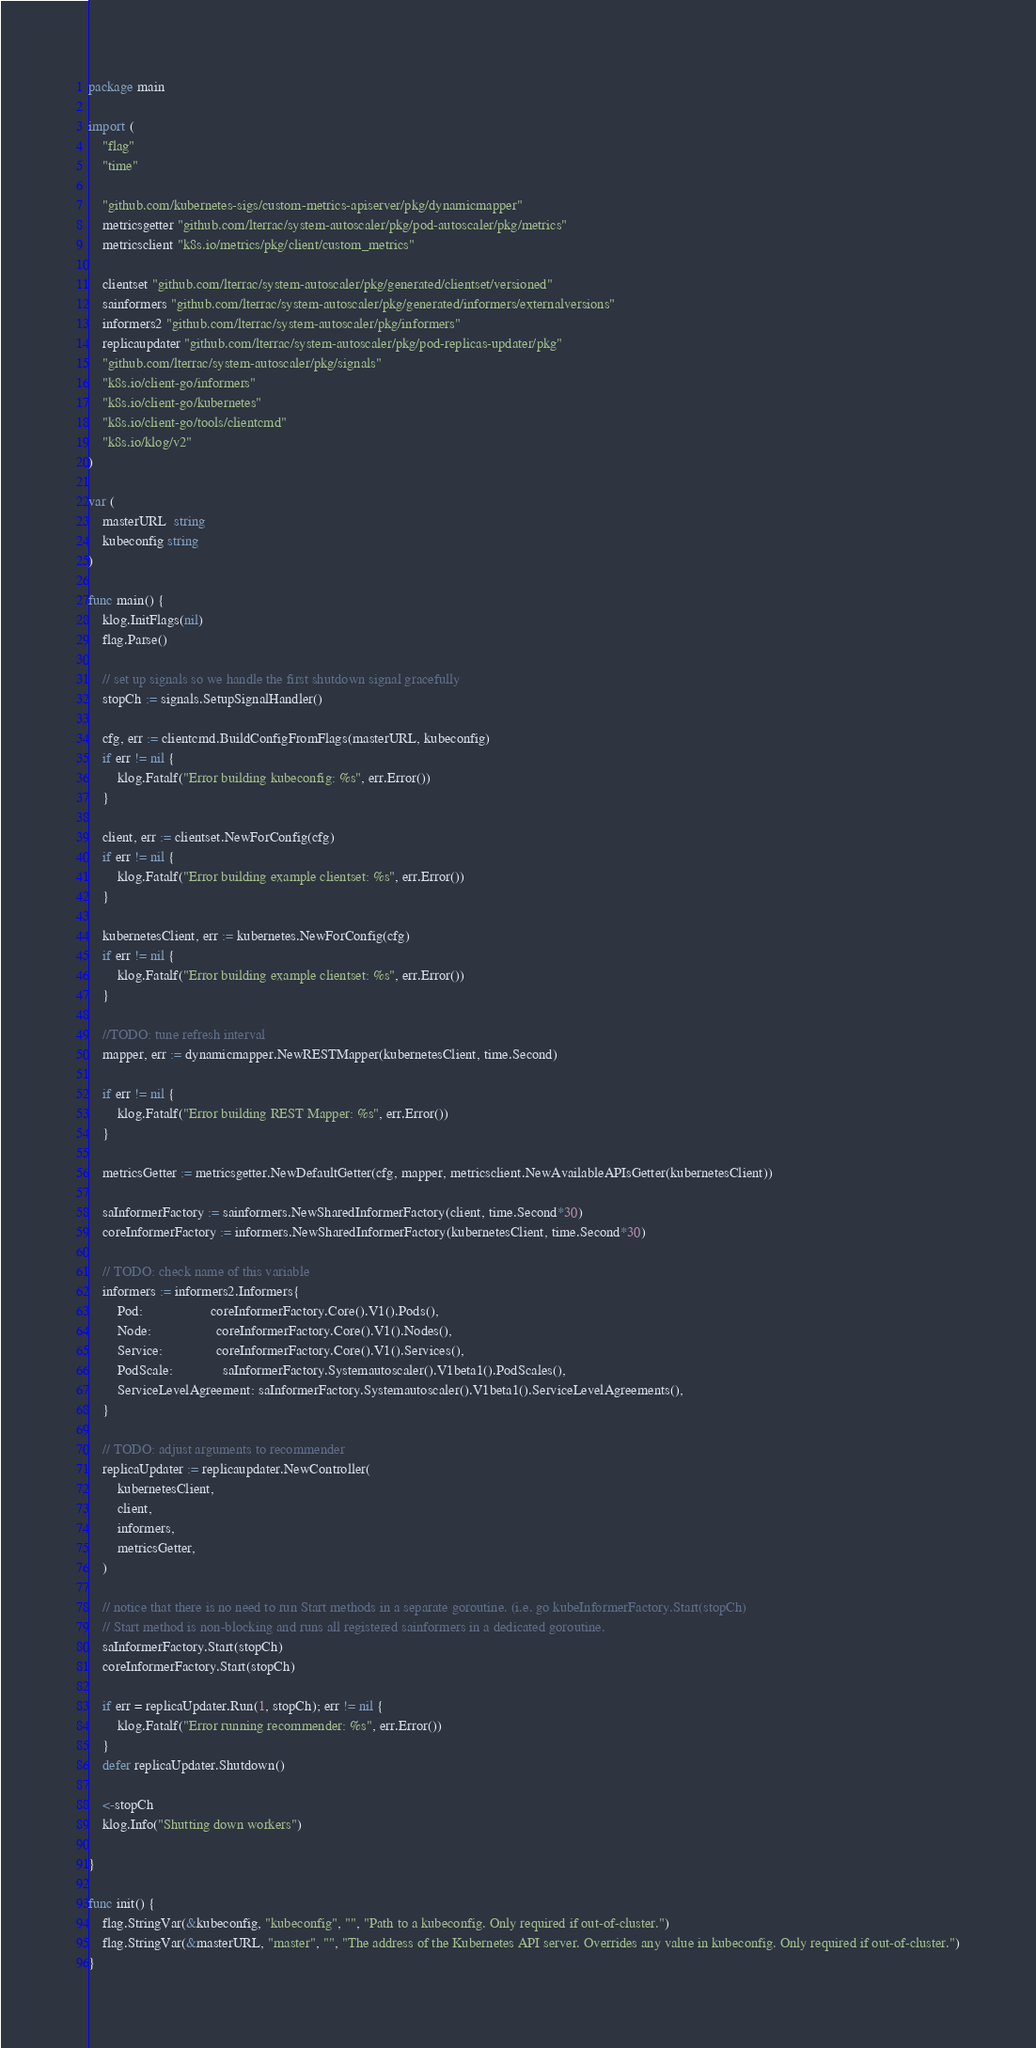Convert code to text. <code><loc_0><loc_0><loc_500><loc_500><_Go_>package main

import (
	"flag"
	"time"

	"github.com/kubernetes-sigs/custom-metrics-apiserver/pkg/dynamicmapper"
	metricsgetter "github.com/lterrac/system-autoscaler/pkg/pod-autoscaler/pkg/metrics"
	metricsclient "k8s.io/metrics/pkg/client/custom_metrics"

	clientset "github.com/lterrac/system-autoscaler/pkg/generated/clientset/versioned"
	sainformers "github.com/lterrac/system-autoscaler/pkg/generated/informers/externalversions"
	informers2 "github.com/lterrac/system-autoscaler/pkg/informers"
	replicaupdater "github.com/lterrac/system-autoscaler/pkg/pod-replicas-updater/pkg"
	"github.com/lterrac/system-autoscaler/pkg/signals"
	"k8s.io/client-go/informers"
	"k8s.io/client-go/kubernetes"
	"k8s.io/client-go/tools/clientcmd"
	"k8s.io/klog/v2"
)

var (
	masterURL  string
	kubeconfig string
)

func main() {
	klog.InitFlags(nil)
	flag.Parse()

	// set up signals so we handle the first shutdown signal gracefully
	stopCh := signals.SetupSignalHandler()

	cfg, err := clientcmd.BuildConfigFromFlags(masterURL, kubeconfig)
	if err != nil {
		klog.Fatalf("Error building kubeconfig: %s", err.Error())
	}

	client, err := clientset.NewForConfig(cfg)
	if err != nil {
		klog.Fatalf("Error building example clientset: %s", err.Error())
	}

	kubernetesClient, err := kubernetes.NewForConfig(cfg)
	if err != nil {
		klog.Fatalf("Error building example clientset: %s", err.Error())
	}

	//TODO: tune refresh interval
	mapper, err := dynamicmapper.NewRESTMapper(kubernetesClient, time.Second)

	if err != nil {
		klog.Fatalf("Error building REST Mapper: %s", err.Error())
	}

	metricsGetter := metricsgetter.NewDefaultGetter(cfg, mapper, metricsclient.NewAvailableAPIsGetter(kubernetesClient))

	saInformerFactory := sainformers.NewSharedInformerFactory(client, time.Second*30)
	coreInformerFactory := informers.NewSharedInformerFactory(kubernetesClient, time.Second*30)

	// TODO: check name of this variable
	informers := informers2.Informers{
		Pod:                   coreInformerFactory.Core().V1().Pods(),
		Node:                  coreInformerFactory.Core().V1().Nodes(),
		Service:               coreInformerFactory.Core().V1().Services(),
		PodScale:              saInformerFactory.Systemautoscaler().V1beta1().PodScales(),
		ServiceLevelAgreement: saInformerFactory.Systemautoscaler().V1beta1().ServiceLevelAgreements(),
	}

	// TODO: adjust arguments to recommender
	replicaUpdater := replicaupdater.NewController(
		kubernetesClient,
		client,
		informers,
		metricsGetter,
	)

	// notice that there is no need to run Start methods in a separate goroutine. (i.e. go kubeInformerFactory.Start(stopCh)
	// Start method is non-blocking and runs all registered sainformers in a dedicated goroutine.
	saInformerFactory.Start(stopCh)
	coreInformerFactory.Start(stopCh)

	if err = replicaUpdater.Run(1, stopCh); err != nil {
		klog.Fatalf("Error running recommender: %s", err.Error())
	}
	defer replicaUpdater.Shutdown()

	<-stopCh
	klog.Info("Shutting down workers")

}

func init() {
	flag.StringVar(&kubeconfig, "kubeconfig", "", "Path to a kubeconfig. Only required if out-of-cluster.")
	flag.StringVar(&masterURL, "master", "", "The address of the Kubernetes API server. Overrides any value in kubeconfig. Only required if out-of-cluster.")
}
</code> 